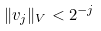Convert formula to latex. <formula><loc_0><loc_0><loc_500><loc_500>\| v _ { j } \| _ { V } < 2 ^ { - j }</formula> 